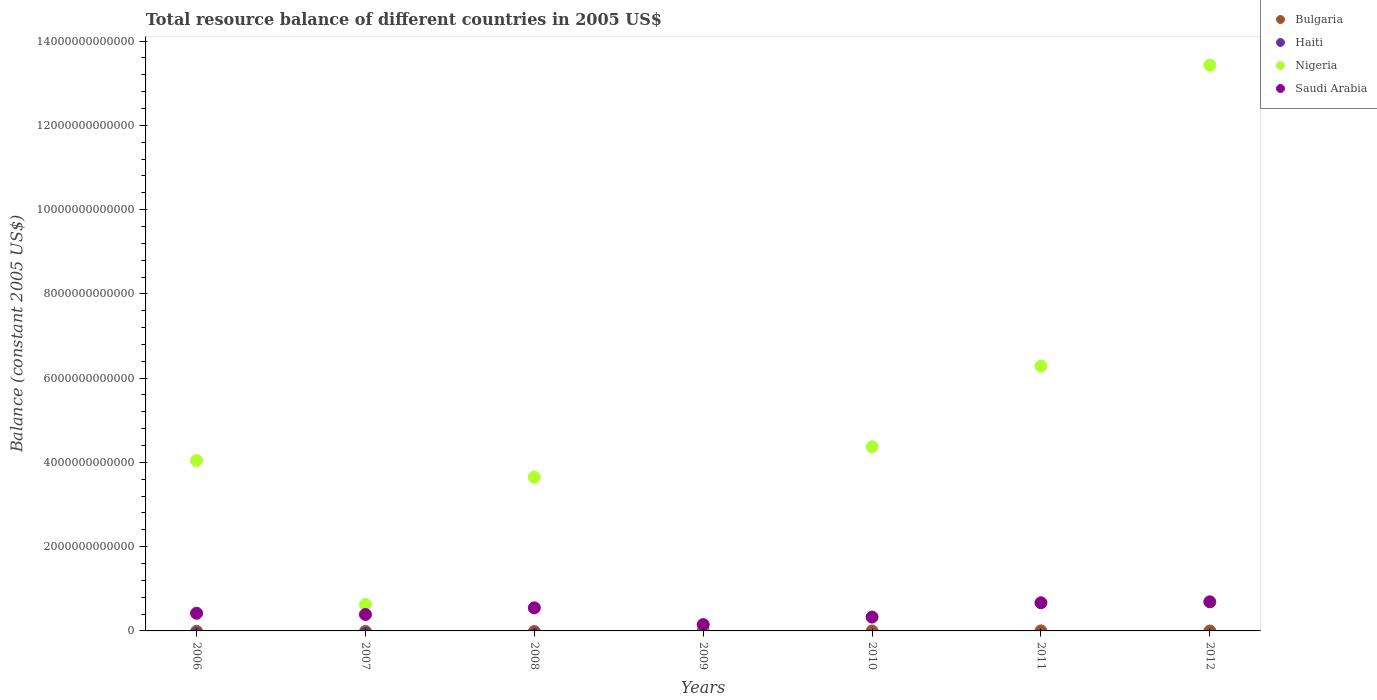Is the number of dotlines equal to the number of legend labels?
Offer a terse response. No. What is the total resource balance in Bulgaria in 2012?
Give a very brief answer. 0. Across all years, what is the maximum total resource balance in Saudi Arabia?
Provide a succinct answer. 6.91e+11. What is the total total resource balance in Saudi Arabia in the graph?
Your answer should be very brief. 3.20e+12. What is the difference between the total resource balance in Saudi Arabia in 2007 and that in 2010?
Give a very brief answer. 6.13e+1. What is the average total resource balance in Nigeria per year?
Provide a short and direct response. 4.63e+12. In the year 2011, what is the difference between the total resource balance in Nigeria and total resource balance in Saudi Arabia?
Keep it short and to the point. 5.62e+12. In how many years, is the total resource balance in Bulgaria greater than 12800000000000 US$?
Ensure brevity in your answer.  0. What is the ratio of the total resource balance in Saudi Arabia in 2009 to that in 2010?
Your answer should be very brief. 0.46. Is the difference between the total resource balance in Nigeria in 2010 and 2011 greater than the difference between the total resource balance in Saudi Arabia in 2010 and 2011?
Offer a very short reply. No. What is the difference between the highest and the second highest total resource balance in Saudi Arabia?
Make the answer very short. 2.24e+1. What is the difference between the highest and the lowest total resource balance in Nigeria?
Ensure brevity in your answer.  1.34e+13. Is it the case that in every year, the sum of the total resource balance in Saudi Arabia and total resource balance in Bulgaria  is greater than the sum of total resource balance in Nigeria and total resource balance in Haiti?
Offer a very short reply. No. How many years are there in the graph?
Give a very brief answer. 7. What is the difference between two consecutive major ticks on the Y-axis?
Your response must be concise. 2.00e+12. Does the graph contain any zero values?
Give a very brief answer. Yes. How many legend labels are there?
Your answer should be compact. 4. How are the legend labels stacked?
Provide a succinct answer. Vertical. What is the title of the graph?
Offer a terse response. Total resource balance of different countries in 2005 US$. Does "Czech Republic" appear as one of the legend labels in the graph?
Make the answer very short. No. What is the label or title of the Y-axis?
Keep it short and to the point. Balance (constant 2005 US$). What is the Balance (constant 2005 US$) in Haiti in 2006?
Your answer should be very brief. 0. What is the Balance (constant 2005 US$) of Nigeria in 2006?
Ensure brevity in your answer.  4.04e+12. What is the Balance (constant 2005 US$) in Saudi Arabia in 2006?
Offer a terse response. 4.19e+11. What is the Balance (constant 2005 US$) of Bulgaria in 2007?
Make the answer very short. 0. What is the Balance (constant 2005 US$) of Nigeria in 2007?
Your answer should be very brief. 6.27e+11. What is the Balance (constant 2005 US$) in Saudi Arabia in 2007?
Give a very brief answer. 3.90e+11. What is the Balance (constant 2005 US$) of Nigeria in 2008?
Offer a very short reply. 3.65e+12. What is the Balance (constant 2005 US$) of Saudi Arabia in 2008?
Provide a short and direct response. 5.48e+11. What is the Balance (constant 2005 US$) in Haiti in 2009?
Your answer should be compact. 0. What is the Balance (constant 2005 US$) of Saudi Arabia in 2009?
Provide a succinct answer. 1.50e+11. What is the Balance (constant 2005 US$) of Haiti in 2010?
Keep it short and to the point. 0. What is the Balance (constant 2005 US$) of Nigeria in 2010?
Give a very brief answer. 4.37e+12. What is the Balance (constant 2005 US$) of Saudi Arabia in 2010?
Your response must be concise. 3.29e+11. What is the Balance (constant 2005 US$) in Bulgaria in 2011?
Give a very brief answer. 7.66e+08. What is the Balance (constant 2005 US$) in Nigeria in 2011?
Make the answer very short. 6.29e+12. What is the Balance (constant 2005 US$) in Saudi Arabia in 2011?
Your answer should be compact. 6.68e+11. What is the Balance (constant 2005 US$) of Bulgaria in 2012?
Offer a terse response. 0. What is the Balance (constant 2005 US$) in Haiti in 2012?
Your response must be concise. 0. What is the Balance (constant 2005 US$) of Nigeria in 2012?
Your answer should be very brief. 1.34e+13. What is the Balance (constant 2005 US$) of Saudi Arabia in 2012?
Your answer should be compact. 6.91e+11. Across all years, what is the maximum Balance (constant 2005 US$) in Bulgaria?
Offer a very short reply. 7.66e+08. Across all years, what is the maximum Balance (constant 2005 US$) in Nigeria?
Provide a succinct answer. 1.34e+13. Across all years, what is the maximum Balance (constant 2005 US$) of Saudi Arabia?
Provide a short and direct response. 6.91e+11. Across all years, what is the minimum Balance (constant 2005 US$) in Saudi Arabia?
Your answer should be compact. 1.50e+11. What is the total Balance (constant 2005 US$) of Bulgaria in the graph?
Keep it short and to the point. 7.66e+08. What is the total Balance (constant 2005 US$) in Nigeria in the graph?
Make the answer very short. 3.24e+13. What is the total Balance (constant 2005 US$) in Saudi Arabia in the graph?
Offer a very short reply. 3.20e+12. What is the difference between the Balance (constant 2005 US$) of Nigeria in 2006 and that in 2007?
Offer a terse response. 3.42e+12. What is the difference between the Balance (constant 2005 US$) in Saudi Arabia in 2006 and that in 2007?
Provide a succinct answer. 2.96e+1. What is the difference between the Balance (constant 2005 US$) in Nigeria in 2006 and that in 2008?
Provide a succinct answer. 3.95e+11. What is the difference between the Balance (constant 2005 US$) in Saudi Arabia in 2006 and that in 2008?
Give a very brief answer. -1.29e+11. What is the difference between the Balance (constant 2005 US$) of Saudi Arabia in 2006 and that in 2009?
Keep it short and to the point. 2.70e+11. What is the difference between the Balance (constant 2005 US$) in Nigeria in 2006 and that in 2010?
Offer a very short reply. -3.25e+11. What is the difference between the Balance (constant 2005 US$) of Saudi Arabia in 2006 and that in 2010?
Offer a very short reply. 9.09e+1. What is the difference between the Balance (constant 2005 US$) in Nigeria in 2006 and that in 2011?
Provide a short and direct response. -2.24e+12. What is the difference between the Balance (constant 2005 US$) of Saudi Arabia in 2006 and that in 2011?
Offer a very short reply. -2.49e+11. What is the difference between the Balance (constant 2005 US$) of Nigeria in 2006 and that in 2012?
Give a very brief answer. -9.39e+12. What is the difference between the Balance (constant 2005 US$) of Saudi Arabia in 2006 and that in 2012?
Make the answer very short. -2.71e+11. What is the difference between the Balance (constant 2005 US$) of Nigeria in 2007 and that in 2008?
Provide a succinct answer. -3.02e+12. What is the difference between the Balance (constant 2005 US$) in Saudi Arabia in 2007 and that in 2008?
Keep it short and to the point. -1.58e+11. What is the difference between the Balance (constant 2005 US$) in Saudi Arabia in 2007 and that in 2009?
Offer a very short reply. 2.40e+11. What is the difference between the Balance (constant 2005 US$) in Nigeria in 2007 and that in 2010?
Give a very brief answer. -3.74e+12. What is the difference between the Balance (constant 2005 US$) of Saudi Arabia in 2007 and that in 2010?
Ensure brevity in your answer.  6.13e+1. What is the difference between the Balance (constant 2005 US$) of Nigeria in 2007 and that in 2011?
Provide a succinct answer. -5.66e+12. What is the difference between the Balance (constant 2005 US$) in Saudi Arabia in 2007 and that in 2011?
Your answer should be very brief. -2.79e+11. What is the difference between the Balance (constant 2005 US$) in Nigeria in 2007 and that in 2012?
Offer a terse response. -1.28e+13. What is the difference between the Balance (constant 2005 US$) of Saudi Arabia in 2007 and that in 2012?
Ensure brevity in your answer.  -3.01e+11. What is the difference between the Balance (constant 2005 US$) in Saudi Arabia in 2008 and that in 2009?
Offer a very short reply. 3.98e+11. What is the difference between the Balance (constant 2005 US$) in Nigeria in 2008 and that in 2010?
Make the answer very short. -7.20e+11. What is the difference between the Balance (constant 2005 US$) in Saudi Arabia in 2008 and that in 2010?
Make the answer very short. 2.20e+11. What is the difference between the Balance (constant 2005 US$) in Nigeria in 2008 and that in 2011?
Give a very brief answer. -2.64e+12. What is the difference between the Balance (constant 2005 US$) in Saudi Arabia in 2008 and that in 2011?
Your answer should be very brief. -1.20e+11. What is the difference between the Balance (constant 2005 US$) in Nigeria in 2008 and that in 2012?
Keep it short and to the point. -9.78e+12. What is the difference between the Balance (constant 2005 US$) of Saudi Arabia in 2008 and that in 2012?
Make the answer very short. -1.43e+11. What is the difference between the Balance (constant 2005 US$) of Saudi Arabia in 2009 and that in 2010?
Your answer should be very brief. -1.79e+11. What is the difference between the Balance (constant 2005 US$) in Saudi Arabia in 2009 and that in 2011?
Offer a very short reply. -5.18e+11. What is the difference between the Balance (constant 2005 US$) in Saudi Arabia in 2009 and that in 2012?
Ensure brevity in your answer.  -5.41e+11. What is the difference between the Balance (constant 2005 US$) in Nigeria in 2010 and that in 2011?
Your answer should be very brief. -1.92e+12. What is the difference between the Balance (constant 2005 US$) in Saudi Arabia in 2010 and that in 2011?
Provide a succinct answer. -3.40e+11. What is the difference between the Balance (constant 2005 US$) in Nigeria in 2010 and that in 2012?
Make the answer very short. -9.06e+12. What is the difference between the Balance (constant 2005 US$) of Saudi Arabia in 2010 and that in 2012?
Offer a very short reply. -3.62e+11. What is the difference between the Balance (constant 2005 US$) of Nigeria in 2011 and that in 2012?
Give a very brief answer. -7.14e+12. What is the difference between the Balance (constant 2005 US$) of Saudi Arabia in 2011 and that in 2012?
Offer a terse response. -2.24e+1. What is the difference between the Balance (constant 2005 US$) of Nigeria in 2006 and the Balance (constant 2005 US$) of Saudi Arabia in 2007?
Give a very brief answer. 3.65e+12. What is the difference between the Balance (constant 2005 US$) in Nigeria in 2006 and the Balance (constant 2005 US$) in Saudi Arabia in 2008?
Offer a terse response. 3.50e+12. What is the difference between the Balance (constant 2005 US$) of Nigeria in 2006 and the Balance (constant 2005 US$) of Saudi Arabia in 2009?
Keep it short and to the point. 3.89e+12. What is the difference between the Balance (constant 2005 US$) of Nigeria in 2006 and the Balance (constant 2005 US$) of Saudi Arabia in 2010?
Your answer should be very brief. 3.72e+12. What is the difference between the Balance (constant 2005 US$) of Nigeria in 2006 and the Balance (constant 2005 US$) of Saudi Arabia in 2011?
Your response must be concise. 3.38e+12. What is the difference between the Balance (constant 2005 US$) in Nigeria in 2006 and the Balance (constant 2005 US$) in Saudi Arabia in 2012?
Offer a terse response. 3.35e+12. What is the difference between the Balance (constant 2005 US$) of Nigeria in 2007 and the Balance (constant 2005 US$) of Saudi Arabia in 2008?
Make the answer very short. 7.89e+1. What is the difference between the Balance (constant 2005 US$) in Nigeria in 2007 and the Balance (constant 2005 US$) in Saudi Arabia in 2009?
Keep it short and to the point. 4.77e+11. What is the difference between the Balance (constant 2005 US$) of Nigeria in 2007 and the Balance (constant 2005 US$) of Saudi Arabia in 2010?
Your answer should be very brief. 2.98e+11. What is the difference between the Balance (constant 2005 US$) in Nigeria in 2007 and the Balance (constant 2005 US$) in Saudi Arabia in 2011?
Give a very brief answer. -4.14e+1. What is the difference between the Balance (constant 2005 US$) in Nigeria in 2007 and the Balance (constant 2005 US$) in Saudi Arabia in 2012?
Give a very brief answer. -6.38e+1. What is the difference between the Balance (constant 2005 US$) in Nigeria in 2008 and the Balance (constant 2005 US$) in Saudi Arabia in 2009?
Offer a terse response. 3.50e+12. What is the difference between the Balance (constant 2005 US$) in Nigeria in 2008 and the Balance (constant 2005 US$) in Saudi Arabia in 2010?
Offer a very short reply. 3.32e+12. What is the difference between the Balance (constant 2005 US$) of Nigeria in 2008 and the Balance (constant 2005 US$) of Saudi Arabia in 2011?
Ensure brevity in your answer.  2.98e+12. What is the difference between the Balance (constant 2005 US$) in Nigeria in 2008 and the Balance (constant 2005 US$) in Saudi Arabia in 2012?
Ensure brevity in your answer.  2.96e+12. What is the difference between the Balance (constant 2005 US$) of Nigeria in 2010 and the Balance (constant 2005 US$) of Saudi Arabia in 2011?
Ensure brevity in your answer.  3.70e+12. What is the difference between the Balance (constant 2005 US$) of Nigeria in 2010 and the Balance (constant 2005 US$) of Saudi Arabia in 2012?
Give a very brief answer. 3.68e+12. What is the difference between the Balance (constant 2005 US$) of Bulgaria in 2011 and the Balance (constant 2005 US$) of Nigeria in 2012?
Provide a succinct answer. -1.34e+13. What is the difference between the Balance (constant 2005 US$) of Bulgaria in 2011 and the Balance (constant 2005 US$) of Saudi Arabia in 2012?
Your response must be concise. -6.90e+11. What is the difference between the Balance (constant 2005 US$) of Nigeria in 2011 and the Balance (constant 2005 US$) of Saudi Arabia in 2012?
Your answer should be very brief. 5.59e+12. What is the average Balance (constant 2005 US$) in Bulgaria per year?
Ensure brevity in your answer.  1.09e+08. What is the average Balance (constant 2005 US$) of Nigeria per year?
Your response must be concise. 4.63e+12. What is the average Balance (constant 2005 US$) in Saudi Arabia per year?
Your answer should be very brief. 4.56e+11. In the year 2006, what is the difference between the Balance (constant 2005 US$) of Nigeria and Balance (constant 2005 US$) of Saudi Arabia?
Make the answer very short. 3.62e+12. In the year 2007, what is the difference between the Balance (constant 2005 US$) in Nigeria and Balance (constant 2005 US$) in Saudi Arabia?
Ensure brevity in your answer.  2.37e+11. In the year 2008, what is the difference between the Balance (constant 2005 US$) in Nigeria and Balance (constant 2005 US$) in Saudi Arabia?
Offer a terse response. 3.10e+12. In the year 2010, what is the difference between the Balance (constant 2005 US$) of Nigeria and Balance (constant 2005 US$) of Saudi Arabia?
Your answer should be compact. 4.04e+12. In the year 2011, what is the difference between the Balance (constant 2005 US$) in Bulgaria and Balance (constant 2005 US$) in Nigeria?
Give a very brief answer. -6.28e+12. In the year 2011, what is the difference between the Balance (constant 2005 US$) of Bulgaria and Balance (constant 2005 US$) of Saudi Arabia?
Provide a short and direct response. -6.68e+11. In the year 2011, what is the difference between the Balance (constant 2005 US$) in Nigeria and Balance (constant 2005 US$) in Saudi Arabia?
Your answer should be compact. 5.62e+12. In the year 2012, what is the difference between the Balance (constant 2005 US$) of Nigeria and Balance (constant 2005 US$) of Saudi Arabia?
Make the answer very short. 1.27e+13. What is the ratio of the Balance (constant 2005 US$) of Nigeria in 2006 to that in 2007?
Your answer should be compact. 6.45. What is the ratio of the Balance (constant 2005 US$) in Saudi Arabia in 2006 to that in 2007?
Ensure brevity in your answer.  1.08. What is the ratio of the Balance (constant 2005 US$) in Nigeria in 2006 to that in 2008?
Keep it short and to the point. 1.11. What is the ratio of the Balance (constant 2005 US$) in Saudi Arabia in 2006 to that in 2008?
Make the answer very short. 0.77. What is the ratio of the Balance (constant 2005 US$) of Saudi Arabia in 2006 to that in 2009?
Offer a very short reply. 2.8. What is the ratio of the Balance (constant 2005 US$) in Nigeria in 2006 to that in 2010?
Provide a short and direct response. 0.93. What is the ratio of the Balance (constant 2005 US$) of Saudi Arabia in 2006 to that in 2010?
Your response must be concise. 1.28. What is the ratio of the Balance (constant 2005 US$) of Nigeria in 2006 to that in 2011?
Give a very brief answer. 0.64. What is the ratio of the Balance (constant 2005 US$) of Saudi Arabia in 2006 to that in 2011?
Your answer should be very brief. 0.63. What is the ratio of the Balance (constant 2005 US$) of Nigeria in 2006 to that in 2012?
Make the answer very short. 0.3. What is the ratio of the Balance (constant 2005 US$) in Saudi Arabia in 2006 to that in 2012?
Offer a terse response. 0.61. What is the ratio of the Balance (constant 2005 US$) in Nigeria in 2007 to that in 2008?
Give a very brief answer. 0.17. What is the ratio of the Balance (constant 2005 US$) in Saudi Arabia in 2007 to that in 2008?
Your response must be concise. 0.71. What is the ratio of the Balance (constant 2005 US$) of Saudi Arabia in 2007 to that in 2009?
Offer a terse response. 2.6. What is the ratio of the Balance (constant 2005 US$) of Nigeria in 2007 to that in 2010?
Your answer should be compact. 0.14. What is the ratio of the Balance (constant 2005 US$) in Saudi Arabia in 2007 to that in 2010?
Your answer should be compact. 1.19. What is the ratio of the Balance (constant 2005 US$) of Nigeria in 2007 to that in 2011?
Your answer should be very brief. 0.1. What is the ratio of the Balance (constant 2005 US$) of Saudi Arabia in 2007 to that in 2011?
Offer a terse response. 0.58. What is the ratio of the Balance (constant 2005 US$) in Nigeria in 2007 to that in 2012?
Your answer should be compact. 0.05. What is the ratio of the Balance (constant 2005 US$) in Saudi Arabia in 2007 to that in 2012?
Keep it short and to the point. 0.56. What is the ratio of the Balance (constant 2005 US$) of Saudi Arabia in 2008 to that in 2009?
Your answer should be very brief. 3.66. What is the ratio of the Balance (constant 2005 US$) in Nigeria in 2008 to that in 2010?
Give a very brief answer. 0.84. What is the ratio of the Balance (constant 2005 US$) of Saudi Arabia in 2008 to that in 2010?
Make the answer very short. 1.67. What is the ratio of the Balance (constant 2005 US$) of Nigeria in 2008 to that in 2011?
Ensure brevity in your answer.  0.58. What is the ratio of the Balance (constant 2005 US$) of Saudi Arabia in 2008 to that in 2011?
Give a very brief answer. 0.82. What is the ratio of the Balance (constant 2005 US$) in Nigeria in 2008 to that in 2012?
Provide a succinct answer. 0.27. What is the ratio of the Balance (constant 2005 US$) in Saudi Arabia in 2008 to that in 2012?
Your answer should be very brief. 0.79. What is the ratio of the Balance (constant 2005 US$) of Saudi Arabia in 2009 to that in 2010?
Provide a short and direct response. 0.46. What is the ratio of the Balance (constant 2005 US$) of Saudi Arabia in 2009 to that in 2011?
Provide a succinct answer. 0.22. What is the ratio of the Balance (constant 2005 US$) of Saudi Arabia in 2009 to that in 2012?
Keep it short and to the point. 0.22. What is the ratio of the Balance (constant 2005 US$) of Nigeria in 2010 to that in 2011?
Offer a terse response. 0.7. What is the ratio of the Balance (constant 2005 US$) of Saudi Arabia in 2010 to that in 2011?
Your answer should be compact. 0.49. What is the ratio of the Balance (constant 2005 US$) in Nigeria in 2010 to that in 2012?
Keep it short and to the point. 0.33. What is the ratio of the Balance (constant 2005 US$) of Saudi Arabia in 2010 to that in 2012?
Ensure brevity in your answer.  0.48. What is the ratio of the Balance (constant 2005 US$) of Nigeria in 2011 to that in 2012?
Provide a short and direct response. 0.47. What is the ratio of the Balance (constant 2005 US$) of Saudi Arabia in 2011 to that in 2012?
Offer a very short reply. 0.97. What is the difference between the highest and the second highest Balance (constant 2005 US$) of Nigeria?
Offer a very short reply. 7.14e+12. What is the difference between the highest and the second highest Balance (constant 2005 US$) of Saudi Arabia?
Ensure brevity in your answer.  2.24e+1. What is the difference between the highest and the lowest Balance (constant 2005 US$) of Bulgaria?
Offer a very short reply. 7.66e+08. What is the difference between the highest and the lowest Balance (constant 2005 US$) of Nigeria?
Ensure brevity in your answer.  1.34e+13. What is the difference between the highest and the lowest Balance (constant 2005 US$) of Saudi Arabia?
Provide a short and direct response. 5.41e+11. 